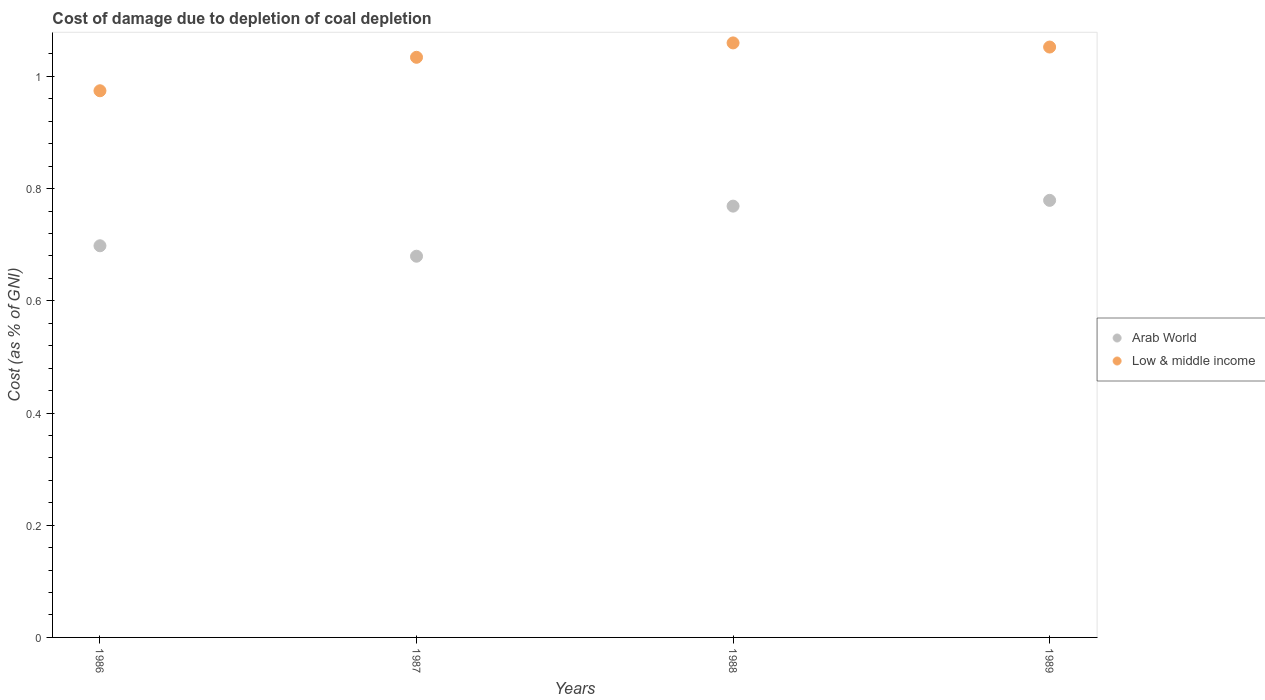How many different coloured dotlines are there?
Provide a succinct answer. 2. Is the number of dotlines equal to the number of legend labels?
Your answer should be very brief. Yes. What is the cost of damage caused due to coal depletion in Arab World in 1986?
Offer a terse response. 0.7. Across all years, what is the maximum cost of damage caused due to coal depletion in Arab World?
Offer a terse response. 0.78. Across all years, what is the minimum cost of damage caused due to coal depletion in Low & middle income?
Ensure brevity in your answer.  0.97. What is the total cost of damage caused due to coal depletion in Arab World in the graph?
Make the answer very short. 2.93. What is the difference between the cost of damage caused due to coal depletion in Low & middle income in 1987 and that in 1989?
Provide a succinct answer. -0.02. What is the difference between the cost of damage caused due to coal depletion in Low & middle income in 1989 and the cost of damage caused due to coal depletion in Arab World in 1987?
Keep it short and to the point. 0.37. What is the average cost of damage caused due to coal depletion in Low & middle income per year?
Give a very brief answer. 1.03. In the year 1989, what is the difference between the cost of damage caused due to coal depletion in Low & middle income and cost of damage caused due to coal depletion in Arab World?
Your response must be concise. 0.27. What is the ratio of the cost of damage caused due to coal depletion in Low & middle income in 1988 to that in 1989?
Provide a short and direct response. 1.01. Is the difference between the cost of damage caused due to coal depletion in Low & middle income in 1987 and 1988 greater than the difference between the cost of damage caused due to coal depletion in Arab World in 1987 and 1988?
Make the answer very short. Yes. What is the difference between the highest and the second highest cost of damage caused due to coal depletion in Arab World?
Your response must be concise. 0.01. What is the difference between the highest and the lowest cost of damage caused due to coal depletion in Arab World?
Provide a short and direct response. 0.1. In how many years, is the cost of damage caused due to coal depletion in Arab World greater than the average cost of damage caused due to coal depletion in Arab World taken over all years?
Ensure brevity in your answer.  2. Is the sum of the cost of damage caused due to coal depletion in Low & middle income in 1987 and 1988 greater than the maximum cost of damage caused due to coal depletion in Arab World across all years?
Make the answer very short. Yes. Does the cost of damage caused due to coal depletion in Low & middle income monotonically increase over the years?
Ensure brevity in your answer.  No. Is the cost of damage caused due to coal depletion in Arab World strictly greater than the cost of damage caused due to coal depletion in Low & middle income over the years?
Your response must be concise. No. Is the cost of damage caused due to coal depletion in Arab World strictly less than the cost of damage caused due to coal depletion in Low & middle income over the years?
Ensure brevity in your answer.  Yes. Are the values on the major ticks of Y-axis written in scientific E-notation?
Provide a short and direct response. No. Does the graph contain any zero values?
Your answer should be very brief. No. How many legend labels are there?
Your answer should be very brief. 2. How are the legend labels stacked?
Your answer should be very brief. Vertical. What is the title of the graph?
Give a very brief answer. Cost of damage due to depletion of coal depletion. Does "Middle East & North Africa (all income levels)" appear as one of the legend labels in the graph?
Make the answer very short. No. What is the label or title of the X-axis?
Your answer should be compact. Years. What is the label or title of the Y-axis?
Offer a terse response. Cost (as % of GNI). What is the Cost (as % of GNI) of Arab World in 1986?
Your response must be concise. 0.7. What is the Cost (as % of GNI) in Low & middle income in 1986?
Keep it short and to the point. 0.97. What is the Cost (as % of GNI) of Arab World in 1987?
Your answer should be very brief. 0.68. What is the Cost (as % of GNI) of Low & middle income in 1987?
Offer a terse response. 1.03. What is the Cost (as % of GNI) of Arab World in 1988?
Make the answer very short. 0.77. What is the Cost (as % of GNI) in Low & middle income in 1988?
Keep it short and to the point. 1.06. What is the Cost (as % of GNI) of Arab World in 1989?
Offer a very short reply. 0.78. What is the Cost (as % of GNI) in Low & middle income in 1989?
Your answer should be compact. 1.05. Across all years, what is the maximum Cost (as % of GNI) in Arab World?
Provide a succinct answer. 0.78. Across all years, what is the maximum Cost (as % of GNI) of Low & middle income?
Make the answer very short. 1.06. Across all years, what is the minimum Cost (as % of GNI) of Arab World?
Offer a very short reply. 0.68. Across all years, what is the minimum Cost (as % of GNI) in Low & middle income?
Ensure brevity in your answer.  0.97. What is the total Cost (as % of GNI) in Arab World in the graph?
Keep it short and to the point. 2.93. What is the total Cost (as % of GNI) of Low & middle income in the graph?
Provide a succinct answer. 4.12. What is the difference between the Cost (as % of GNI) of Arab World in 1986 and that in 1987?
Provide a succinct answer. 0.02. What is the difference between the Cost (as % of GNI) in Low & middle income in 1986 and that in 1987?
Give a very brief answer. -0.06. What is the difference between the Cost (as % of GNI) of Arab World in 1986 and that in 1988?
Your response must be concise. -0.07. What is the difference between the Cost (as % of GNI) of Low & middle income in 1986 and that in 1988?
Provide a short and direct response. -0.09. What is the difference between the Cost (as % of GNI) in Arab World in 1986 and that in 1989?
Your answer should be compact. -0.08. What is the difference between the Cost (as % of GNI) in Low & middle income in 1986 and that in 1989?
Provide a short and direct response. -0.08. What is the difference between the Cost (as % of GNI) in Arab World in 1987 and that in 1988?
Ensure brevity in your answer.  -0.09. What is the difference between the Cost (as % of GNI) of Low & middle income in 1987 and that in 1988?
Offer a very short reply. -0.03. What is the difference between the Cost (as % of GNI) in Arab World in 1987 and that in 1989?
Your answer should be compact. -0.1. What is the difference between the Cost (as % of GNI) of Low & middle income in 1987 and that in 1989?
Provide a short and direct response. -0.02. What is the difference between the Cost (as % of GNI) in Arab World in 1988 and that in 1989?
Keep it short and to the point. -0.01. What is the difference between the Cost (as % of GNI) of Low & middle income in 1988 and that in 1989?
Offer a very short reply. 0.01. What is the difference between the Cost (as % of GNI) of Arab World in 1986 and the Cost (as % of GNI) of Low & middle income in 1987?
Offer a terse response. -0.34. What is the difference between the Cost (as % of GNI) in Arab World in 1986 and the Cost (as % of GNI) in Low & middle income in 1988?
Your answer should be very brief. -0.36. What is the difference between the Cost (as % of GNI) in Arab World in 1986 and the Cost (as % of GNI) in Low & middle income in 1989?
Offer a very short reply. -0.35. What is the difference between the Cost (as % of GNI) in Arab World in 1987 and the Cost (as % of GNI) in Low & middle income in 1988?
Give a very brief answer. -0.38. What is the difference between the Cost (as % of GNI) in Arab World in 1987 and the Cost (as % of GNI) in Low & middle income in 1989?
Ensure brevity in your answer.  -0.37. What is the difference between the Cost (as % of GNI) in Arab World in 1988 and the Cost (as % of GNI) in Low & middle income in 1989?
Keep it short and to the point. -0.28. What is the average Cost (as % of GNI) in Arab World per year?
Keep it short and to the point. 0.73. In the year 1986, what is the difference between the Cost (as % of GNI) of Arab World and Cost (as % of GNI) of Low & middle income?
Your response must be concise. -0.28. In the year 1987, what is the difference between the Cost (as % of GNI) in Arab World and Cost (as % of GNI) in Low & middle income?
Provide a short and direct response. -0.35. In the year 1988, what is the difference between the Cost (as % of GNI) in Arab World and Cost (as % of GNI) in Low & middle income?
Offer a very short reply. -0.29. In the year 1989, what is the difference between the Cost (as % of GNI) of Arab World and Cost (as % of GNI) of Low & middle income?
Your answer should be compact. -0.27. What is the ratio of the Cost (as % of GNI) of Arab World in 1986 to that in 1987?
Provide a short and direct response. 1.03. What is the ratio of the Cost (as % of GNI) in Low & middle income in 1986 to that in 1987?
Ensure brevity in your answer.  0.94. What is the ratio of the Cost (as % of GNI) in Arab World in 1986 to that in 1988?
Your answer should be compact. 0.91. What is the ratio of the Cost (as % of GNI) in Low & middle income in 1986 to that in 1988?
Keep it short and to the point. 0.92. What is the ratio of the Cost (as % of GNI) in Arab World in 1986 to that in 1989?
Make the answer very short. 0.9. What is the ratio of the Cost (as % of GNI) in Low & middle income in 1986 to that in 1989?
Your answer should be very brief. 0.93. What is the ratio of the Cost (as % of GNI) in Arab World in 1987 to that in 1988?
Provide a succinct answer. 0.88. What is the ratio of the Cost (as % of GNI) of Low & middle income in 1987 to that in 1988?
Give a very brief answer. 0.98. What is the ratio of the Cost (as % of GNI) of Arab World in 1987 to that in 1989?
Provide a short and direct response. 0.87. What is the ratio of the Cost (as % of GNI) of Low & middle income in 1987 to that in 1989?
Offer a very short reply. 0.98. What is the ratio of the Cost (as % of GNI) in Arab World in 1988 to that in 1989?
Make the answer very short. 0.99. What is the ratio of the Cost (as % of GNI) of Low & middle income in 1988 to that in 1989?
Provide a succinct answer. 1.01. What is the difference between the highest and the second highest Cost (as % of GNI) in Arab World?
Make the answer very short. 0.01. What is the difference between the highest and the second highest Cost (as % of GNI) in Low & middle income?
Your answer should be very brief. 0.01. What is the difference between the highest and the lowest Cost (as % of GNI) of Arab World?
Provide a succinct answer. 0.1. What is the difference between the highest and the lowest Cost (as % of GNI) of Low & middle income?
Your response must be concise. 0.09. 